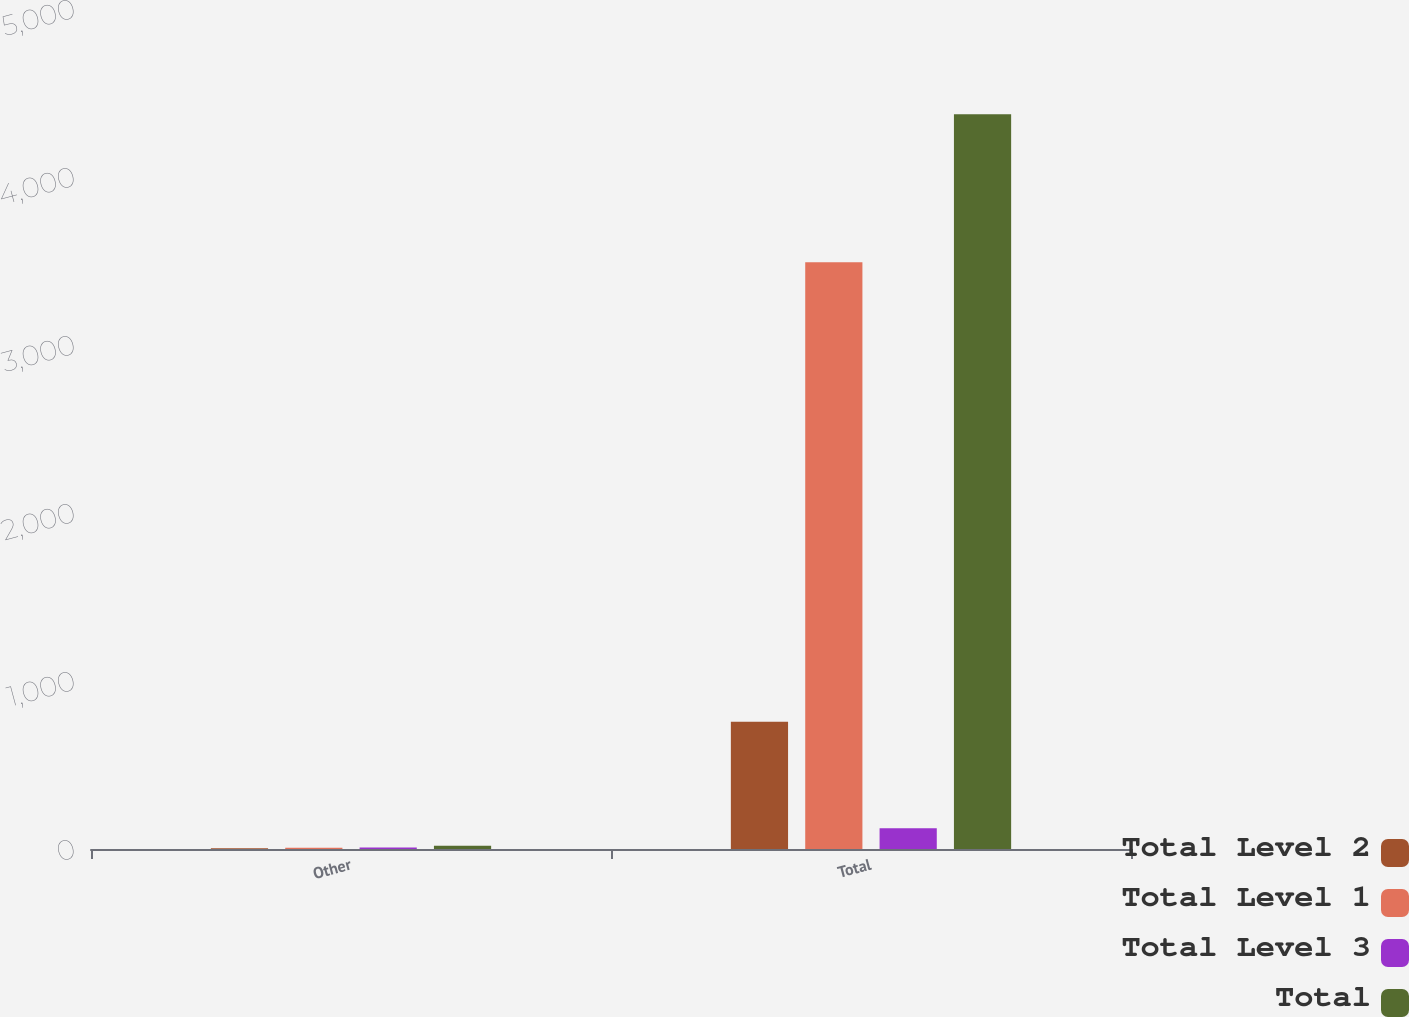Convert chart to OTSL. <chart><loc_0><loc_0><loc_500><loc_500><stacked_bar_chart><ecel><fcel>Other<fcel>Total<nl><fcel>Total Level 2<fcel>4<fcel>758<nl><fcel>Total Level 1<fcel>7<fcel>3492<nl><fcel>Total Level 3<fcel>9<fcel>124<nl><fcel>Total<fcel>20<fcel>4374<nl></chart> 